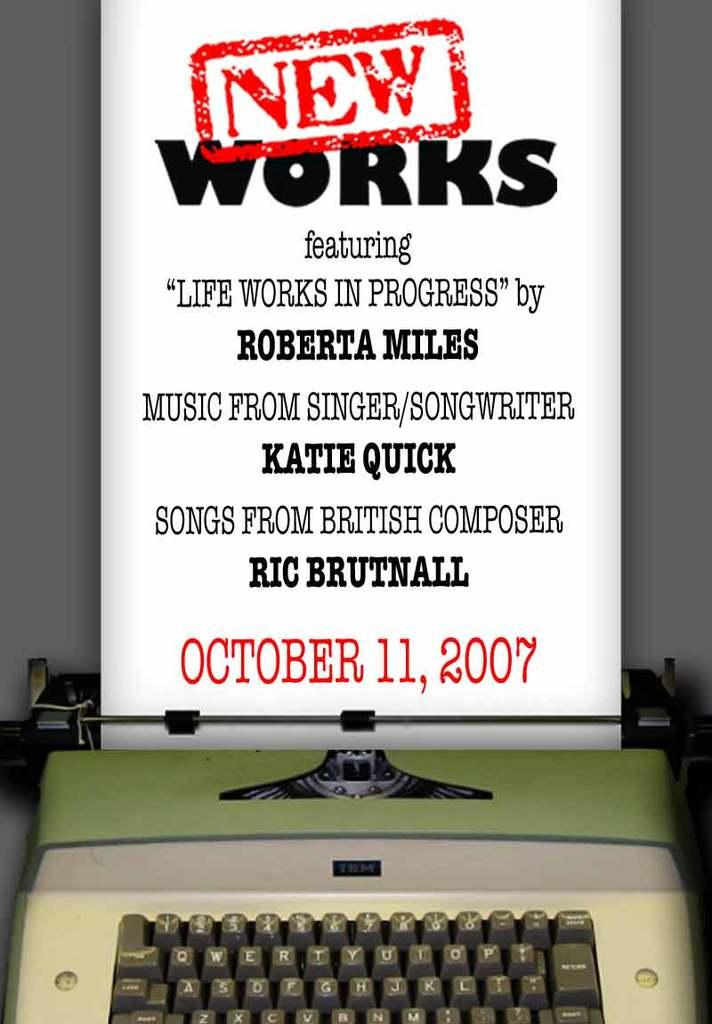<image>
Relay a brief, clear account of the picture shown. A poster from October 11, 2007 hanging over a vintage green typewriter. 